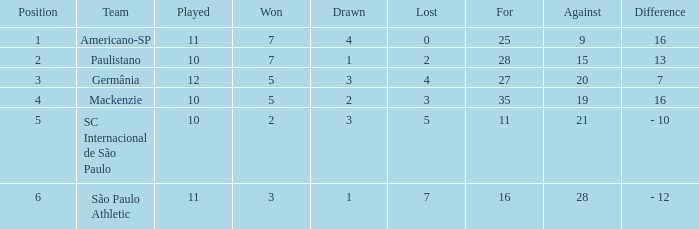Could you help me parse every detail presented in this table? {'header': ['Position', 'Team', 'Played', 'Won', 'Drawn', 'Lost', 'For', 'Against', 'Difference'], 'rows': [['1', 'Americano-SP', '11', '7', '4', '0', '25', '9', '16'], ['2', 'Paulistano', '10', '7', '1', '2', '28', '15', '13'], ['3', 'Germânia', '12', '5', '3', '4', '27', '20', '7'], ['4', 'Mackenzie', '10', '5', '2', '3', '35', '19', '16'], ['5', 'SC Internacional de São Paulo', '10', '2', '3', '5', '11', '21', '- 10'], ['6', 'São Paulo Athletic', '11', '3', '1', '7', '16', '28', '- 12']]} Name the most for when difference is 7 27.0. 